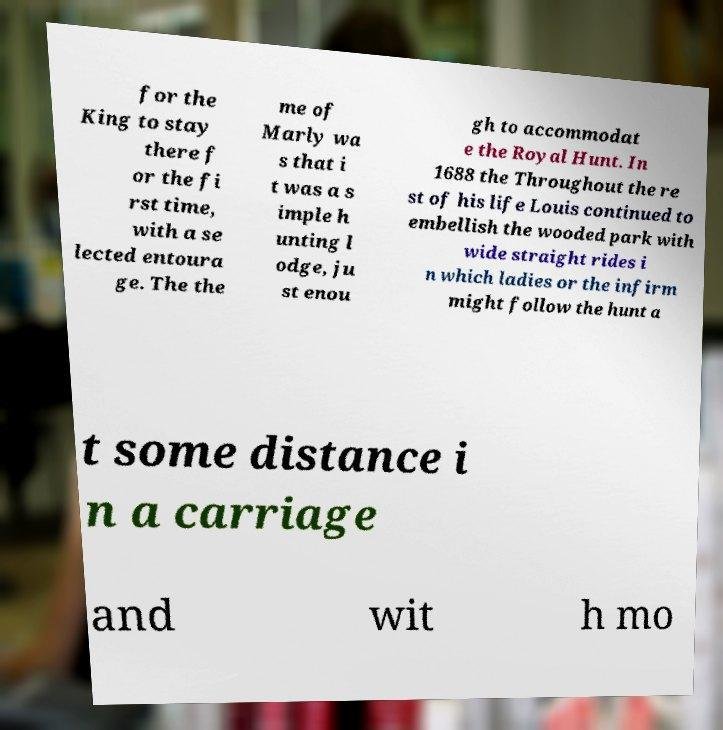Please identify and transcribe the text found in this image. for the King to stay there f or the fi rst time, with a se lected entoura ge. The the me of Marly wa s that i t was a s imple h unting l odge, ju st enou gh to accommodat e the Royal Hunt. In 1688 the Throughout the re st of his life Louis continued to embellish the wooded park with wide straight rides i n which ladies or the infirm might follow the hunt a t some distance i n a carriage and wit h mo 